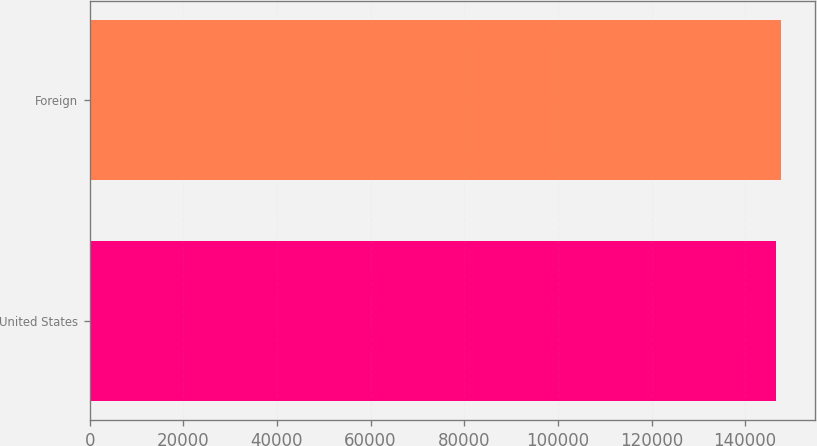Convert chart. <chart><loc_0><loc_0><loc_500><loc_500><bar_chart><fcel>United States<fcel>Foreign<nl><fcel>146575<fcel>147597<nl></chart> 